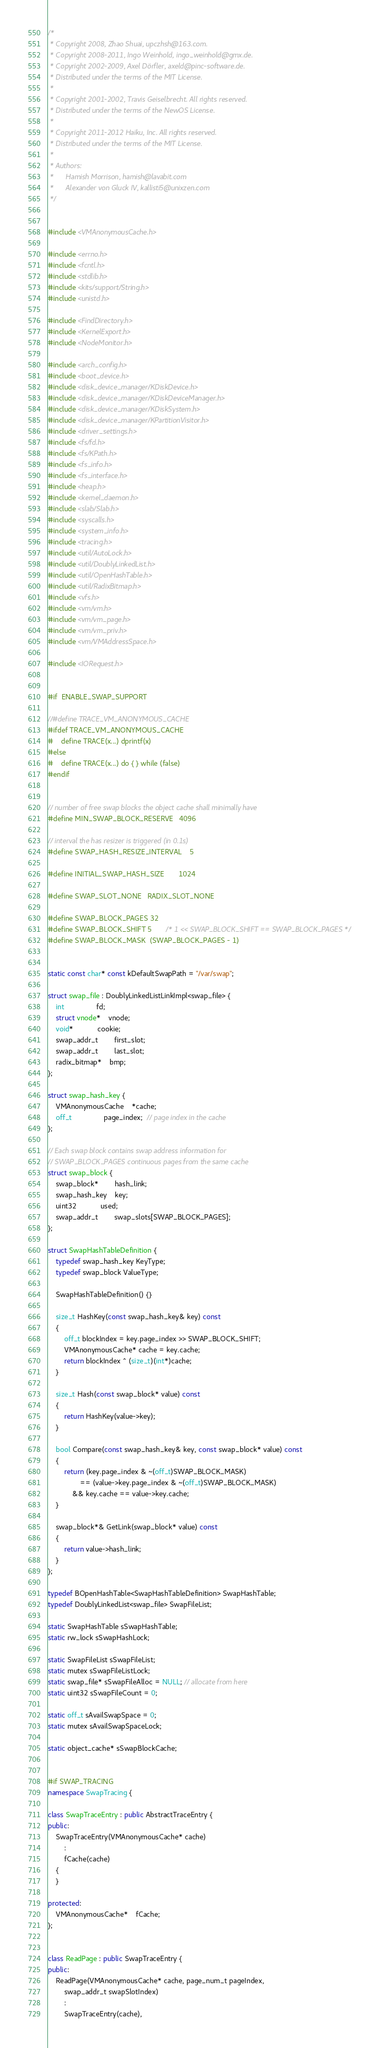<code> <loc_0><loc_0><loc_500><loc_500><_C++_>/*
 * Copyright 2008, Zhao Shuai, upczhsh@163.com.
 * Copyright 2008-2011, Ingo Weinhold, ingo_weinhold@gmx.de.
 * Copyright 2002-2009, Axel Dörfler, axeld@pinc-software.de.
 * Distributed under the terms of the MIT License.
 *
 * Copyright 2001-2002, Travis Geiselbrecht. All rights reserved.
 * Distributed under the terms of the NewOS License.
 *
 * Copyright 2011-2012 Haiku, Inc. All rights reserved.
 * Distributed under the terms of the MIT License.
 *
 * Authors:
 *		Hamish Morrison, hamish@lavabit.com
 *		Alexander von Gluck IV, kallisti5@unixzen.com
 */


#include <VMAnonymousCache.h>

#include <errno.h>
#include <fcntl.h>
#include <stdlib.h>
#include <kits/support/String.h>
#include <unistd.h>

#include <FindDirectory.h>
#include <KernelExport.h>
#include <NodeMonitor.h>

#include <arch_config.h>
#include <boot_device.h>
#include <disk_device_manager/KDiskDevice.h>
#include <disk_device_manager/KDiskDeviceManager.h>
#include <disk_device_manager/KDiskSystem.h>
#include <disk_device_manager/KPartitionVisitor.h>
#include <driver_settings.h>
#include <fs/fd.h>
#include <fs/KPath.h>
#include <fs_info.h>
#include <fs_interface.h>
#include <heap.h>
#include <kernel_daemon.h>
#include <slab/Slab.h>
#include <syscalls.h>
#include <system_info.h>
#include <tracing.h>
#include <util/AutoLock.h>
#include <util/DoublyLinkedList.h>
#include <util/OpenHashTable.h>
#include <util/RadixBitmap.h>
#include <vfs.h>
#include <vm/vm.h>
#include <vm/vm_page.h>
#include <vm/vm_priv.h>
#include <vm/VMAddressSpace.h>

#include <IORequest.h>


#if	ENABLE_SWAP_SUPPORT

//#define TRACE_VM_ANONYMOUS_CACHE
#ifdef TRACE_VM_ANONYMOUS_CACHE
#	define TRACE(x...) dprintf(x)
#else
#	define TRACE(x...) do { } while (false)
#endif


// number of free swap blocks the object cache shall minimally have
#define MIN_SWAP_BLOCK_RESERVE	4096

// interval the has resizer is triggered (in 0.1s)
#define SWAP_HASH_RESIZE_INTERVAL	5

#define INITIAL_SWAP_HASH_SIZE		1024

#define SWAP_SLOT_NONE	RADIX_SLOT_NONE

#define SWAP_BLOCK_PAGES 32
#define SWAP_BLOCK_SHIFT 5		/* 1 << SWAP_BLOCK_SHIFT == SWAP_BLOCK_PAGES */
#define SWAP_BLOCK_MASK  (SWAP_BLOCK_PAGES - 1)


static const char* const kDefaultSwapPath = "/var/swap";

struct swap_file : DoublyLinkedListLinkImpl<swap_file> {
	int				fd;
	struct vnode*	vnode;
	void*			cookie;
	swap_addr_t		first_slot;
	swap_addr_t		last_slot;
	radix_bitmap*	bmp;
};

struct swap_hash_key {
	VMAnonymousCache	*cache;
	off_t				page_index;  // page index in the cache
};

// Each swap block contains swap address information for
// SWAP_BLOCK_PAGES continuous pages from the same cache
struct swap_block {
	swap_block*		hash_link;
	swap_hash_key	key;
	uint32			used;
	swap_addr_t		swap_slots[SWAP_BLOCK_PAGES];
};

struct SwapHashTableDefinition {
	typedef swap_hash_key KeyType;
	typedef swap_block ValueType;

	SwapHashTableDefinition() {}

	size_t HashKey(const swap_hash_key& key) const
	{
		off_t blockIndex = key.page_index >> SWAP_BLOCK_SHIFT;
		VMAnonymousCache* cache = key.cache;
		return blockIndex ^ (size_t)(int*)cache;
	}

	size_t Hash(const swap_block* value) const
	{
		return HashKey(value->key);
	}

	bool Compare(const swap_hash_key& key, const swap_block* value) const
	{
		return (key.page_index & ~(off_t)SWAP_BLOCK_MASK)
				== (value->key.page_index & ~(off_t)SWAP_BLOCK_MASK)
			&& key.cache == value->key.cache;
	}

	swap_block*& GetLink(swap_block* value) const
	{
		return value->hash_link;
	}
};

typedef BOpenHashTable<SwapHashTableDefinition> SwapHashTable;
typedef DoublyLinkedList<swap_file> SwapFileList;

static SwapHashTable sSwapHashTable;
static rw_lock sSwapHashLock;

static SwapFileList sSwapFileList;
static mutex sSwapFileListLock;
static swap_file* sSwapFileAlloc = NULL; // allocate from here
static uint32 sSwapFileCount = 0;

static off_t sAvailSwapSpace = 0;
static mutex sAvailSwapSpaceLock;

static object_cache* sSwapBlockCache;


#if SWAP_TRACING
namespace SwapTracing {

class SwapTraceEntry : public AbstractTraceEntry {
public:
	SwapTraceEntry(VMAnonymousCache* cache)
		:
		fCache(cache)
	{
	}

protected:
	VMAnonymousCache*	fCache;
};


class ReadPage : public SwapTraceEntry {
public:
	ReadPage(VMAnonymousCache* cache, page_num_t pageIndex,
		swap_addr_t swapSlotIndex)
		:
		SwapTraceEntry(cache),</code> 